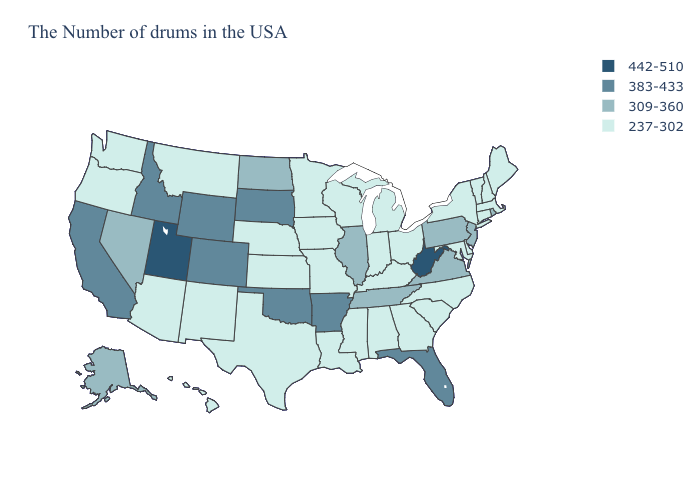Does Montana have the highest value in the West?
Quick response, please. No. Name the states that have a value in the range 237-302?
Write a very short answer. Maine, Massachusetts, New Hampshire, Vermont, Connecticut, New York, Delaware, Maryland, North Carolina, South Carolina, Ohio, Georgia, Michigan, Kentucky, Indiana, Alabama, Wisconsin, Mississippi, Louisiana, Missouri, Minnesota, Iowa, Kansas, Nebraska, Texas, New Mexico, Montana, Arizona, Washington, Oregon, Hawaii. Does New Hampshire have the lowest value in the USA?
Write a very short answer. Yes. Does New Jersey have the lowest value in the Northeast?
Concise answer only. No. Which states have the highest value in the USA?
Write a very short answer. West Virginia, Utah. Name the states that have a value in the range 237-302?
Short answer required. Maine, Massachusetts, New Hampshire, Vermont, Connecticut, New York, Delaware, Maryland, North Carolina, South Carolina, Ohio, Georgia, Michigan, Kentucky, Indiana, Alabama, Wisconsin, Mississippi, Louisiana, Missouri, Minnesota, Iowa, Kansas, Nebraska, Texas, New Mexico, Montana, Arizona, Washington, Oregon, Hawaii. Name the states that have a value in the range 309-360?
Keep it brief. Rhode Island, New Jersey, Pennsylvania, Virginia, Tennessee, Illinois, North Dakota, Nevada, Alaska. What is the lowest value in states that border Virginia?
Answer briefly. 237-302. Which states have the highest value in the USA?
Answer briefly. West Virginia, Utah. What is the value of Iowa?
Short answer required. 237-302. Name the states that have a value in the range 237-302?
Be succinct. Maine, Massachusetts, New Hampshire, Vermont, Connecticut, New York, Delaware, Maryland, North Carolina, South Carolina, Ohio, Georgia, Michigan, Kentucky, Indiana, Alabama, Wisconsin, Mississippi, Louisiana, Missouri, Minnesota, Iowa, Kansas, Nebraska, Texas, New Mexico, Montana, Arizona, Washington, Oregon, Hawaii. Name the states that have a value in the range 442-510?
Quick response, please. West Virginia, Utah. What is the lowest value in the Northeast?
Answer briefly. 237-302. Name the states that have a value in the range 383-433?
Concise answer only. Florida, Arkansas, Oklahoma, South Dakota, Wyoming, Colorado, Idaho, California. Which states have the highest value in the USA?
Give a very brief answer. West Virginia, Utah. 